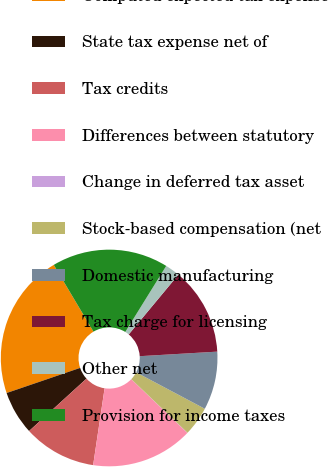<chart> <loc_0><loc_0><loc_500><loc_500><pie_chart><fcel>Computed expected tax expense<fcel>State tax expense net of<fcel>Tax credits<fcel>Differences between statutory<fcel>Change in deferred tax asset<fcel>Stock-based compensation (net<fcel>Domestic manufacturing<fcel>Tax charge for licensing<fcel>Other net<fcel>Provision for income taxes<nl><fcel>21.7%<fcel>6.53%<fcel>10.87%<fcel>15.2%<fcel>0.03%<fcel>4.36%<fcel>8.7%<fcel>13.03%<fcel>2.2%<fcel>17.37%<nl></chart> 